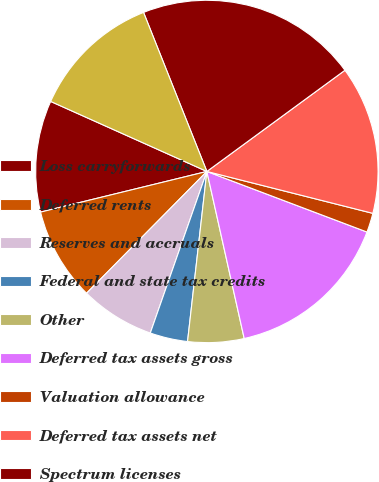Convert chart. <chart><loc_0><loc_0><loc_500><loc_500><pie_chart><fcel>Loss carryforwards<fcel>Deferred rents<fcel>Reserves and accruals<fcel>Federal and state tax credits<fcel>Other<fcel>Deferred tax assets gross<fcel>Valuation allowance<fcel>Deferred tax assets net<fcel>Spectrum licenses<fcel>Property and equipment<nl><fcel>10.52%<fcel>8.78%<fcel>7.04%<fcel>3.56%<fcel>5.3%<fcel>15.74%<fcel>1.82%<fcel>14.0%<fcel>20.96%<fcel>12.26%<nl></chart> 